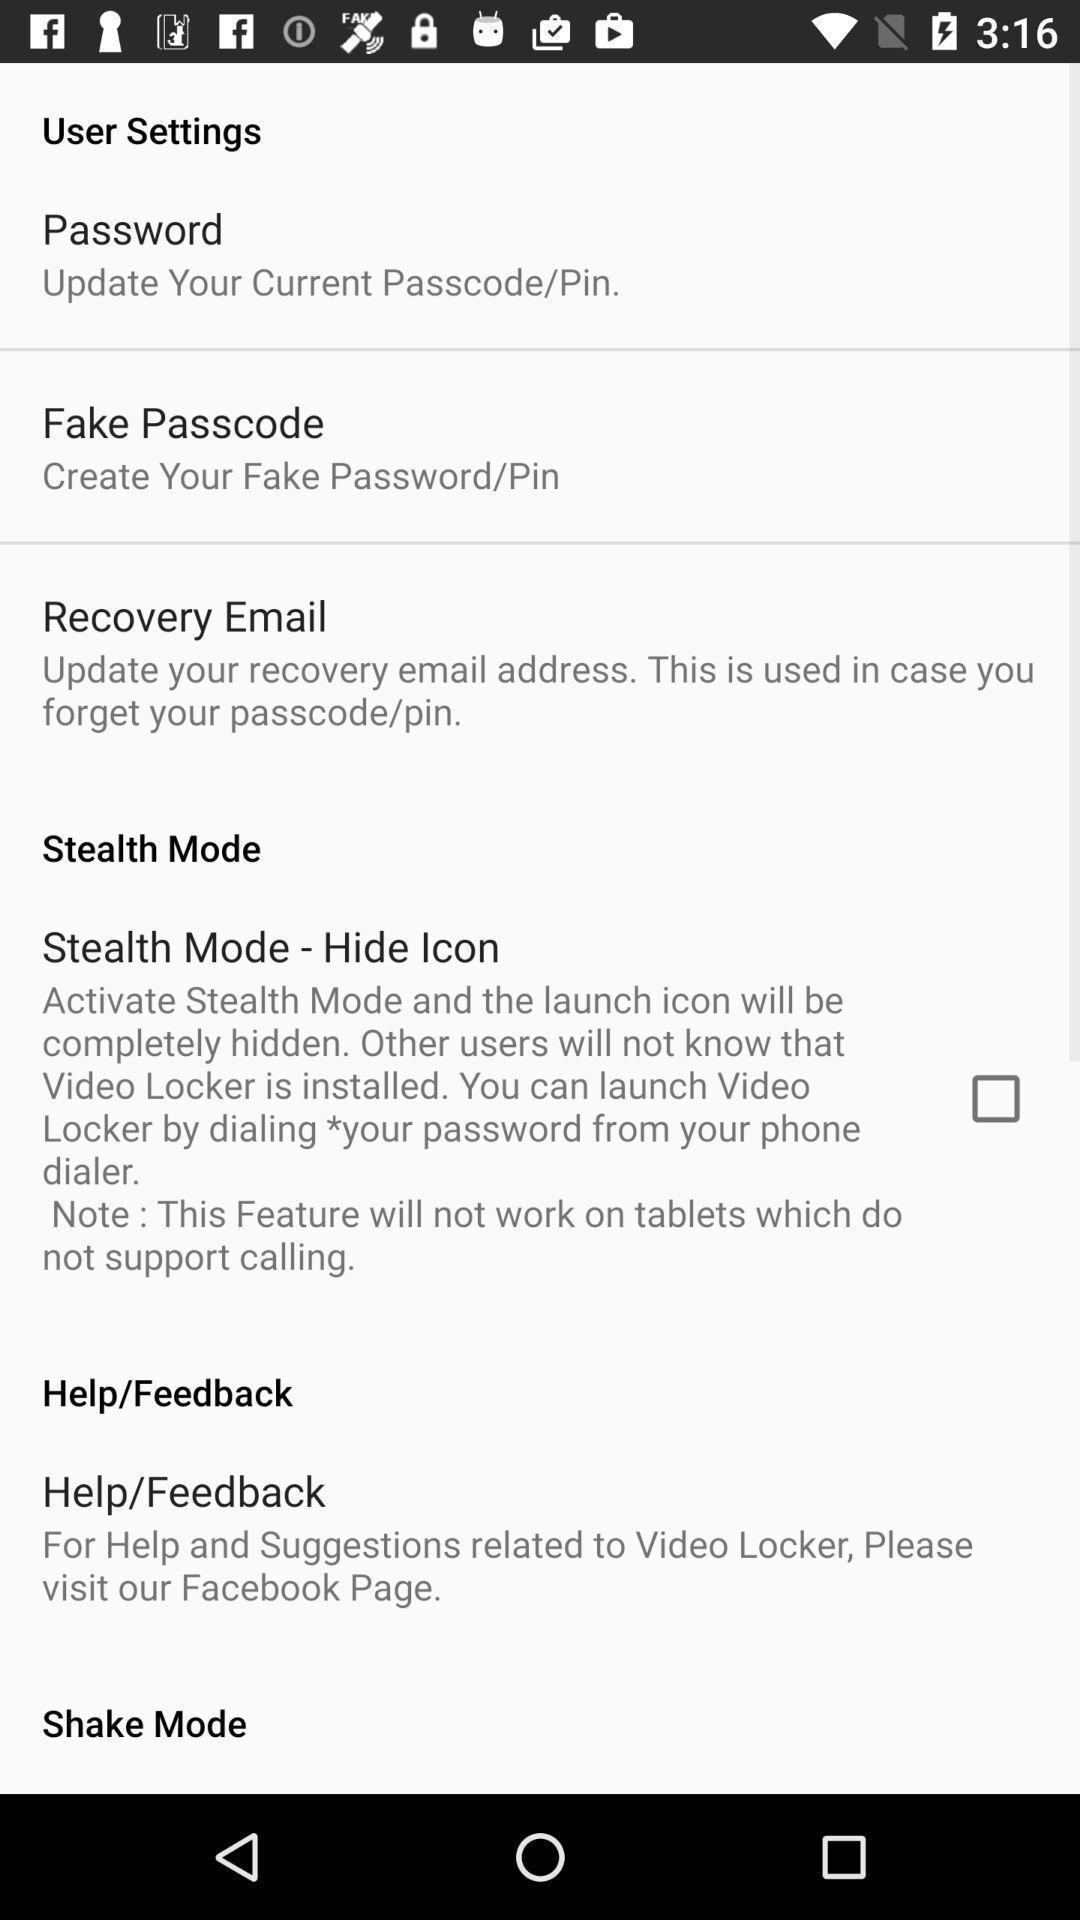Summarize the information in this screenshot. User settings screen with some options in gallery app. 